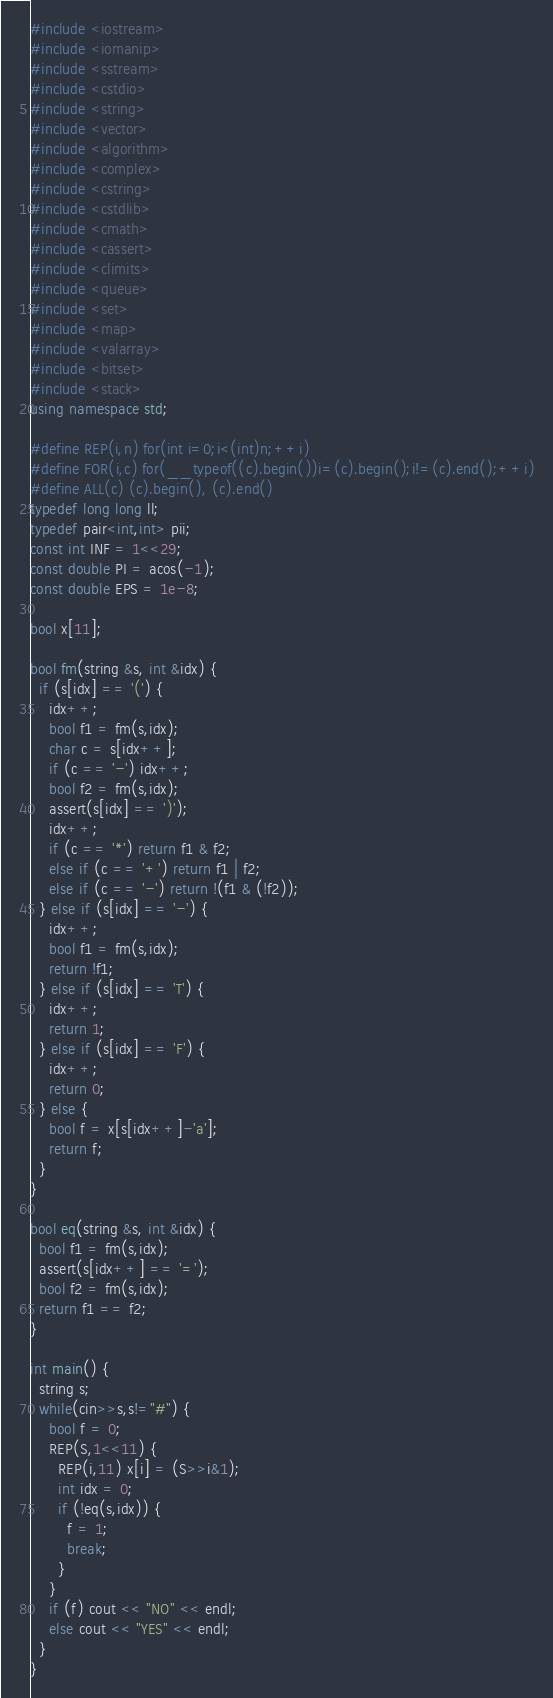Convert code to text. <code><loc_0><loc_0><loc_500><loc_500><_C++_>#include <iostream>
#include <iomanip>
#include <sstream>
#include <cstdio>
#include <string>
#include <vector>
#include <algorithm>
#include <complex>
#include <cstring>
#include <cstdlib>
#include <cmath>
#include <cassert>
#include <climits>
#include <queue>
#include <set>
#include <map>
#include <valarray>
#include <bitset>
#include <stack>
using namespace std;

#define REP(i,n) for(int i=0;i<(int)n;++i)
#define FOR(i,c) for(__typeof((c).begin())i=(c).begin();i!=(c).end();++i)
#define ALL(c) (c).begin(), (c).end()
typedef long long ll;
typedef pair<int,int> pii;
const int INF = 1<<29;
const double PI = acos(-1);
const double EPS = 1e-8;

bool x[11];

bool fm(string &s, int &idx) {
  if (s[idx] == '(') {
    idx++;
    bool f1 = fm(s,idx);
    char c = s[idx++];
    if (c == '-') idx++;
    bool f2 = fm(s,idx);
    assert(s[idx] == ')');
    idx++;
    if (c == '*') return f1 & f2;
    else if (c == '+') return f1 | f2;
    else if (c == '-') return !(f1 & (!f2));
  } else if (s[idx] == '-') {
    idx++;
    bool f1 = fm(s,idx);
    return !f1;
  } else if (s[idx] == 'T') {
    idx++;
    return 1;
  } else if (s[idx] == 'F') {
    idx++;
    return 0;
  } else {
    bool f = x[s[idx++]-'a'];
    return f;
  }
}

bool eq(string &s, int &idx) {
  bool f1 = fm(s,idx);
  assert(s[idx++] == '=');
  bool f2 = fm(s,idx);
  return f1 == f2;
}

int main() {
  string s;
  while(cin>>s,s!="#") {
    bool f = 0;
    REP(S,1<<11) {
      REP(i,11) x[i] = (S>>i&1);
      int idx = 0;
      if (!eq(s,idx)) {
        f = 1;
        break;
      }
    }
    if (f) cout << "NO" << endl;
    else cout << "YES" << endl;
  }
}</code> 